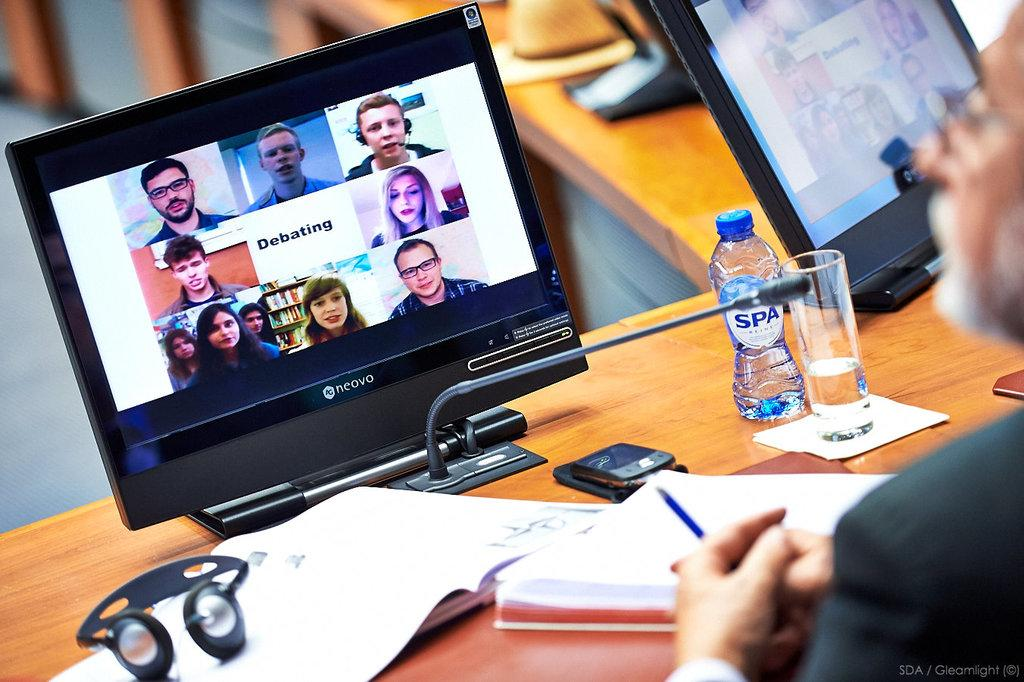Provide a one-sentence caption for the provided image. A man is working at a computer desk with a screen that says Debating. 